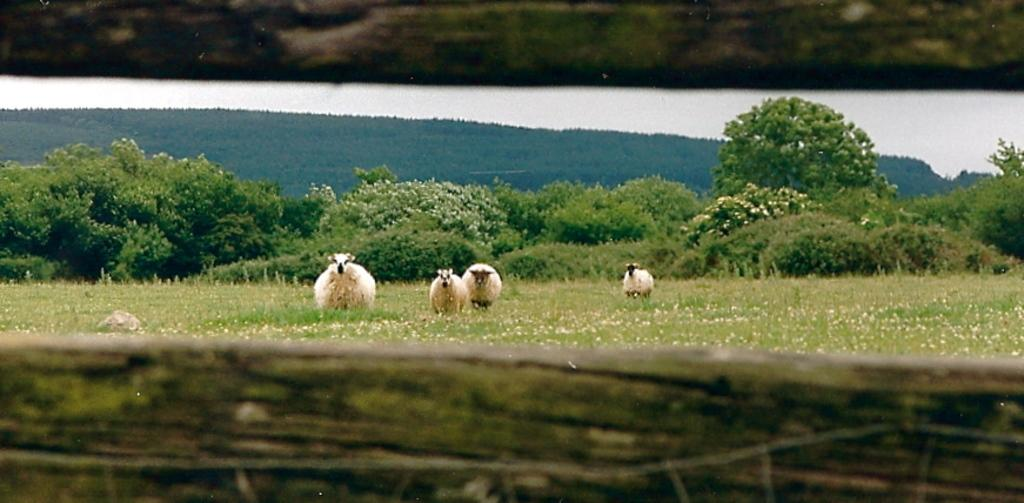How many animals are present in the image? There are four sheep in the image. What type of barrier is at the bottom of the image? There is a wooden fence at the bottom of the image. What type of vegetation is visible in the image? Grass is visible in the image. What can be seen in the background of the image? There are many trees in the background of the image. What type of faucet can be seen in the image? There is no faucet present in the image. How many teeth can be seen on the sheep in the image? Sheep do not have teeth visible like humans, and there are no teeth visible in the image. 